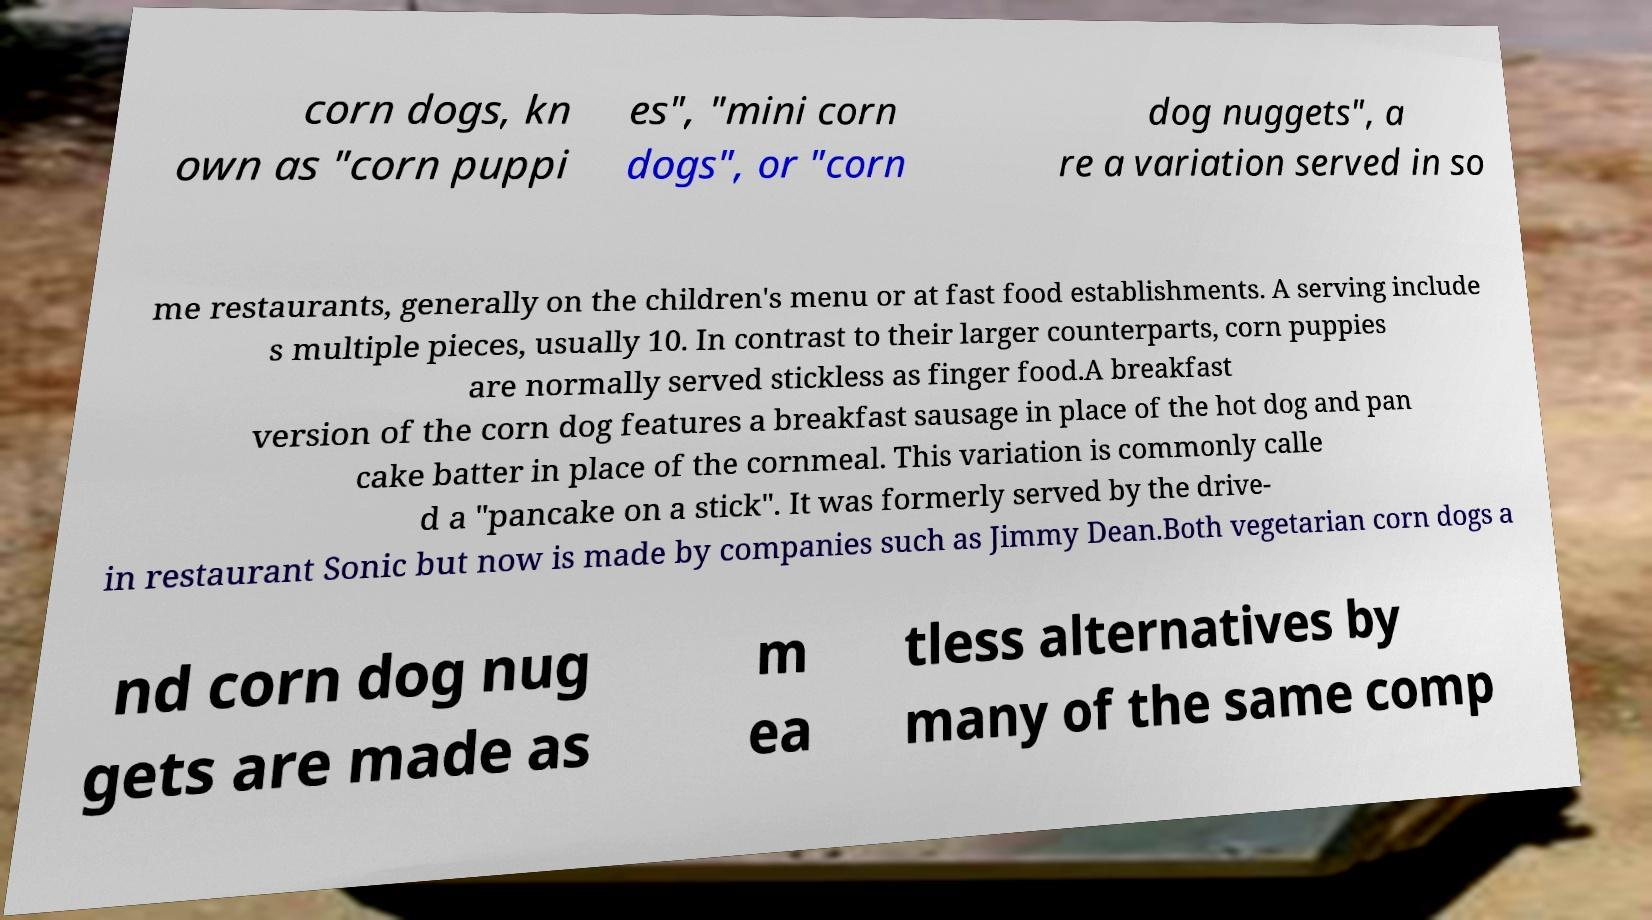Can you accurately transcribe the text from the provided image for me? corn dogs, kn own as "corn puppi es", "mini corn dogs", or "corn dog nuggets", a re a variation served in so me restaurants, generally on the children's menu or at fast food establishments. A serving include s multiple pieces, usually 10. In contrast to their larger counterparts, corn puppies are normally served stickless as finger food.A breakfast version of the corn dog features a breakfast sausage in place of the hot dog and pan cake batter in place of the cornmeal. This variation is commonly calle d a "pancake on a stick". It was formerly served by the drive- in restaurant Sonic but now is made by companies such as Jimmy Dean.Both vegetarian corn dogs a nd corn dog nug gets are made as m ea tless alternatives by many of the same comp 